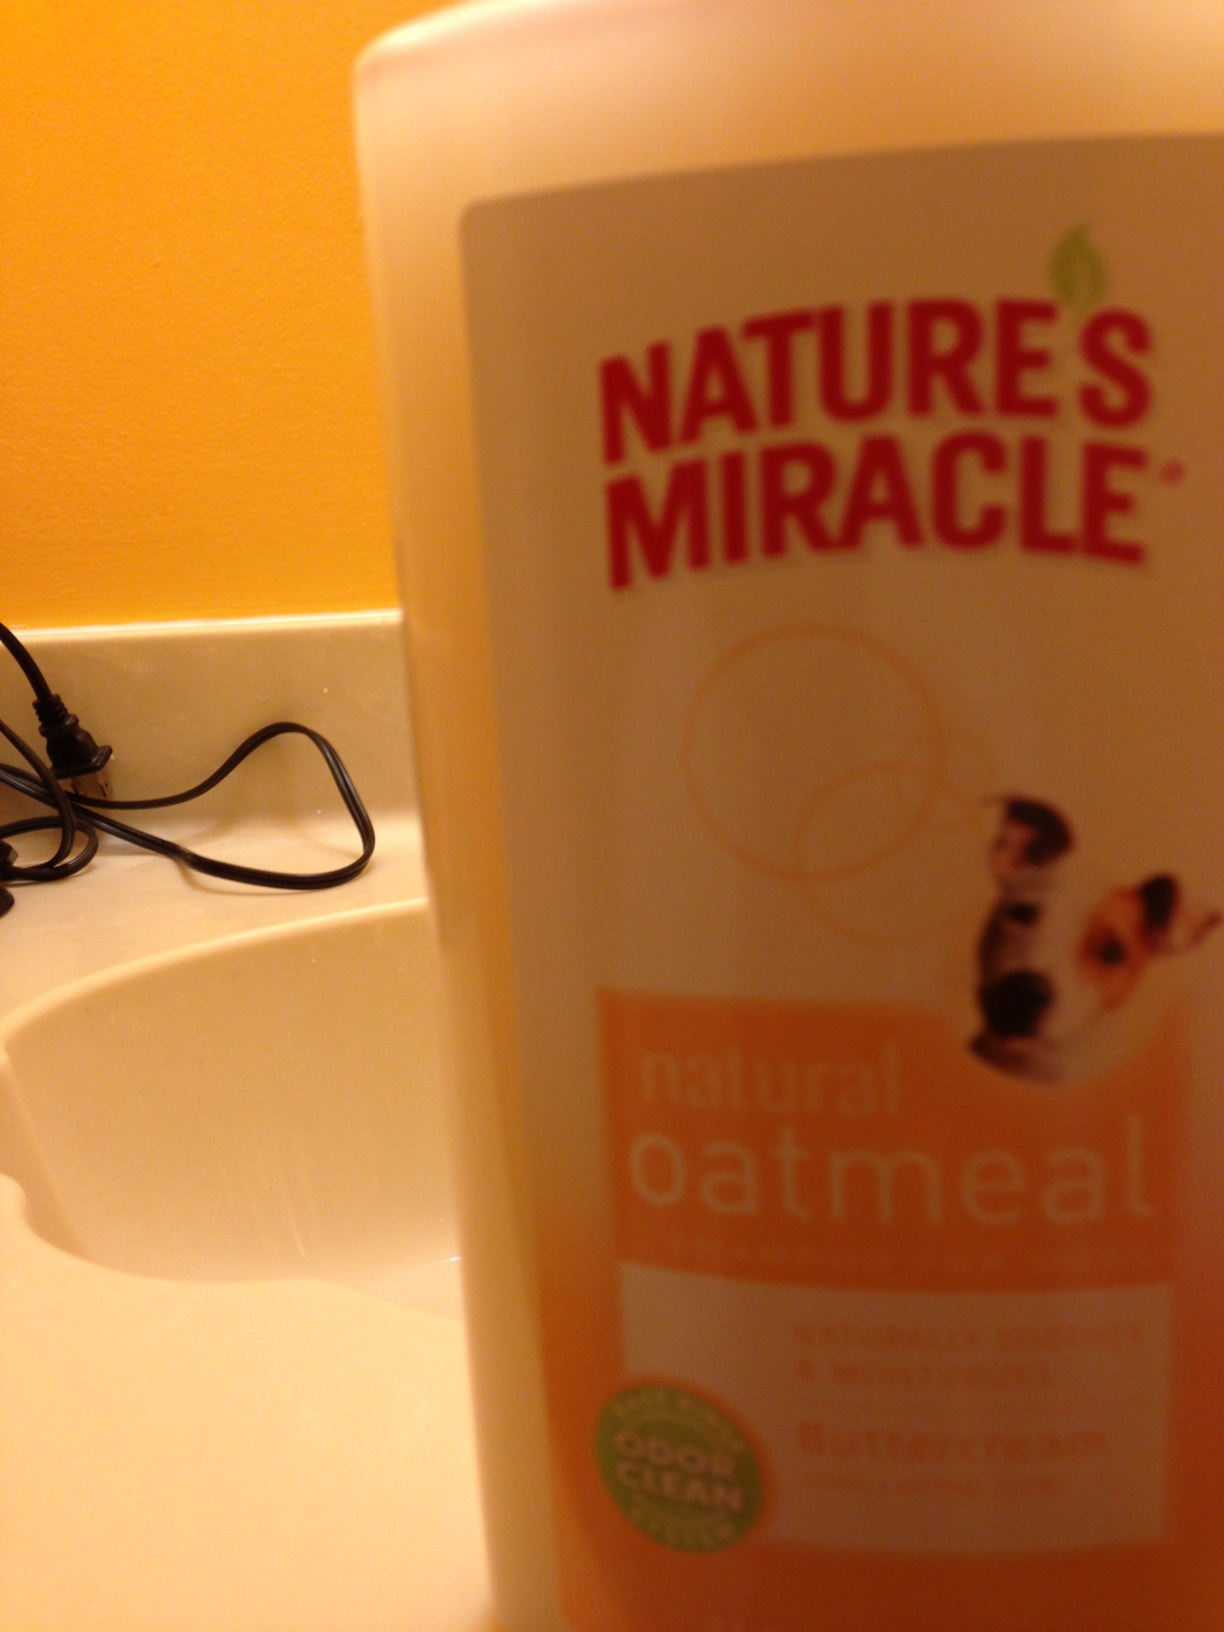What is the name of the product in the picture? The product shown in the image is Nature's Miracle natural oatmeal shampoo. It's formulated with an odor-neutralizing formula and is designed to be soothing for dogs with its oatmeal inclusion, ensuring a cleaner and more pleasant experience for pet grooming. 